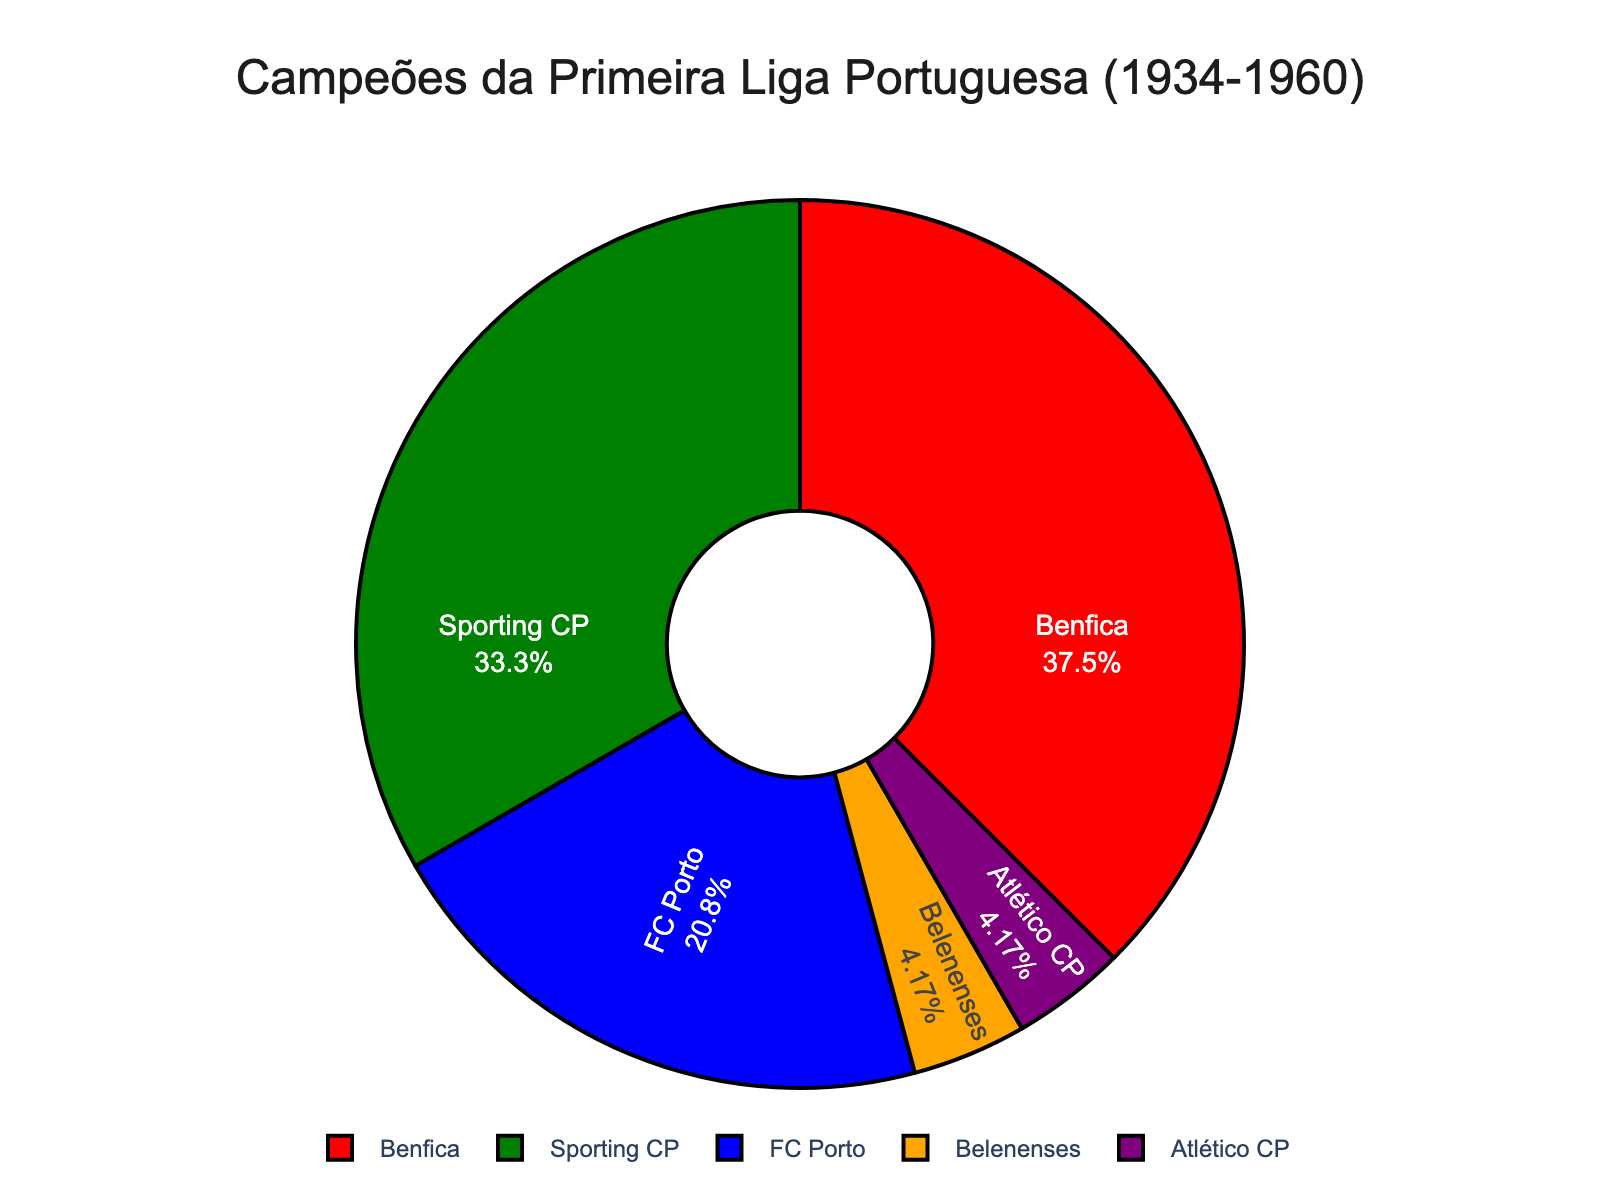what percentage of titles did Benfica win? To find the percentage of titles won by Benfica, locate it in the pie chart and read the percentage directly from there.
Answer: 37.5% Which club has the fewest titles? Look for the smallest segment in the pie chart to identify the club with the fewest titles.
Answer: Belenenses and Atlético CP What is the combined percentage of titles won by both Belenenses and Atlético CP? Find the percentages for Belenenses and Atlético CP in the pie chart, then sum them up.
Answer: 8.33% Which club has more titles, FC Porto or Sporting CP, and by how many? Locate the segments for FC Porto and Sporting CP, note their title counts, and subtract the smaller from the larger.
Answer: Sporting CP, by 3 titles What is the color of the segment representing Sporting CP? Identify the color associated with the Sporting CP segment in the pie chart.
Answer: Green How many more titles does Benfica have than FC Porto? Note the title counts for Benfica and FC Porto from the pie chart, and subtract FC Porto's count from Benfica's.
Answer: 4 What is the total number of titles among all clubs combined? Sum the titles of all clubs shown in the pie chart: 9 (Benfica) + 8 (Sporting CP) + 5 (FC Porto) + 1 (Belenenses) + 1 (Atlético CP).
Answer: 24 What is the title frequency difference between the club with the most titles and the least titles? Identify the clubs with the highest (Benfica) and lowest (Belenenses and Atlético CP) title counts and subtract the lower count from the higher count.
Answer: 8 What percentage of titles did FC Porto and Sporting CP win together? Add the title counts for FC Porto (5) and Sporting CP (8), then divide by the total (24) and multiply by 100 to get the percentage.
Answer: 54.17% If you combine the titles won by Belenenses, Atlético CP, and FC Porto, what fraction of the total does this represent? Sum the title counts for Belenenses (1), Atlético CP (1), and FC Porto (5) to get 7. Then, divide 7 by the total (24) to find the fraction.
Answer: 7/24 